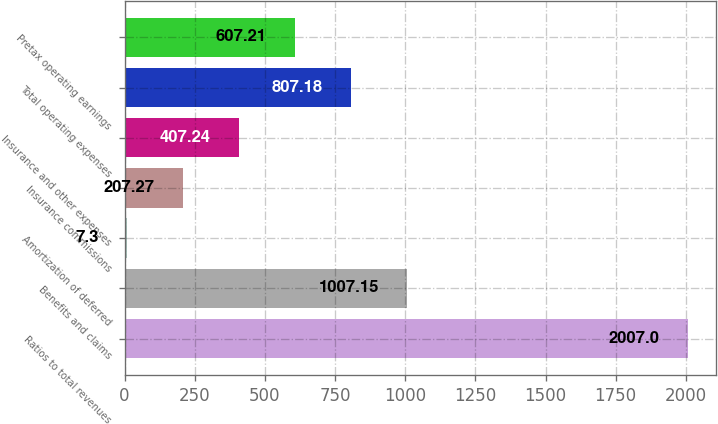Convert chart. <chart><loc_0><loc_0><loc_500><loc_500><bar_chart><fcel>Ratios to total revenues<fcel>Benefits and claims<fcel>Amortization of deferred<fcel>Insurance commissions<fcel>Insurance and other expenses<fcel>Total operating expenses<fcel>Pretax operating earnings<nl><fcel>2007<fcel>1007.15<fcel>7.3<fcel>207.27<fcel>407.24<fcel>807.18<fcel>607.21<nl></chart> 